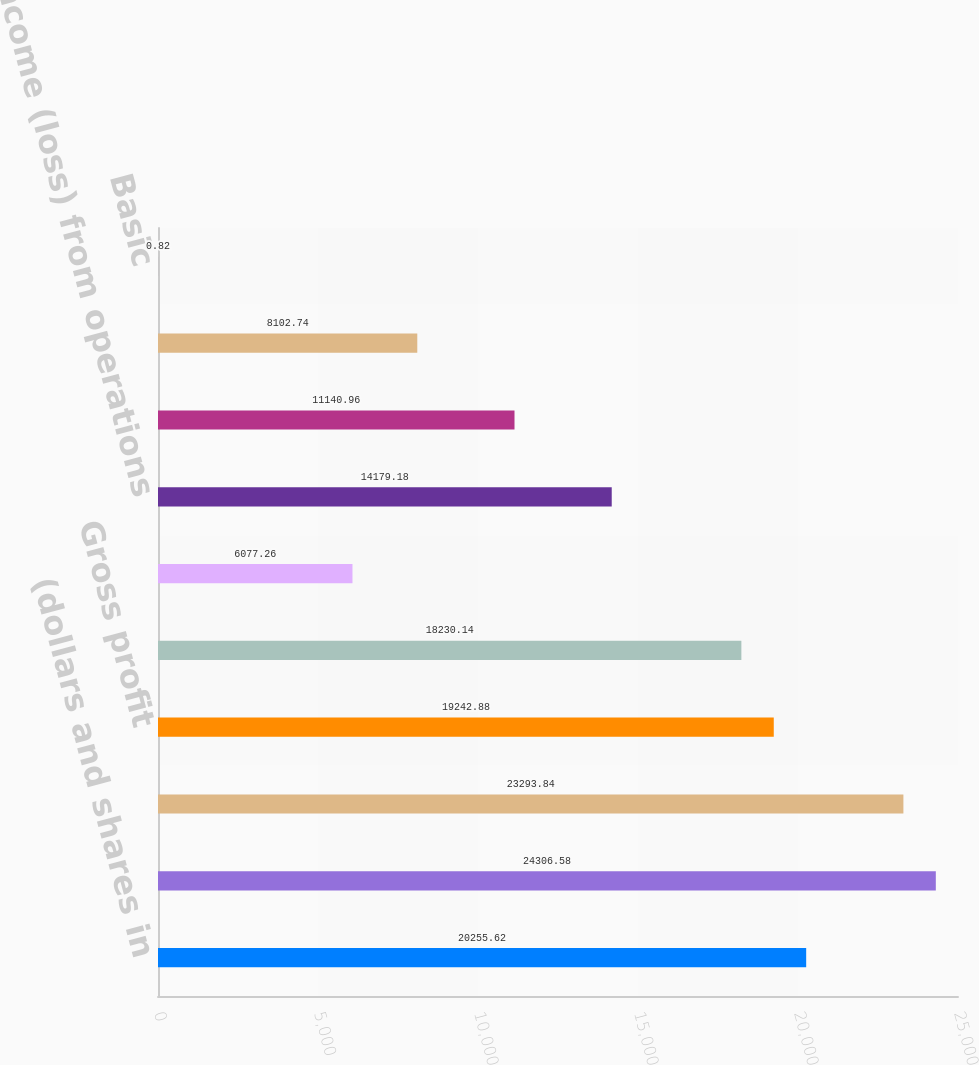Convert chart. <chart><loc_0><loc_0><loc_500><loc_500><bar_chart><fcel>(dollars and shares in<fcel>Net sales<fcel>Cost of sales<fcel>Gross profit<fcel>Selling and administrative<fcel>Advertising expense<fcel>Income (loss) from operations<fcel>Interest expense net<fcel>Income (loss) before income<fcel>Basic<nl><fcel>20255.6<fcel>24306.6<fcel>23293.8<fcel>19242.9<fcel>18230.1<fcel>6077.26<fcel>14179.2<fcel>11141<fcel>8102.74<fcel>0.82<nl></chart> 